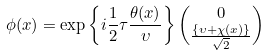Convert formula to latex. <formula><loc_0><loc_0><loc_500><loc_500>\phi ( x ) = \exp \left \{ i \frac { 1 } { 2 } \tau \frac { \theta ( x ) } { \upsilon } \right \} \binom { 0 } { \frac { \left \{ \upsilon + \chi ( x ) \right \} } { \sqrt { 2 } } }</formula> 